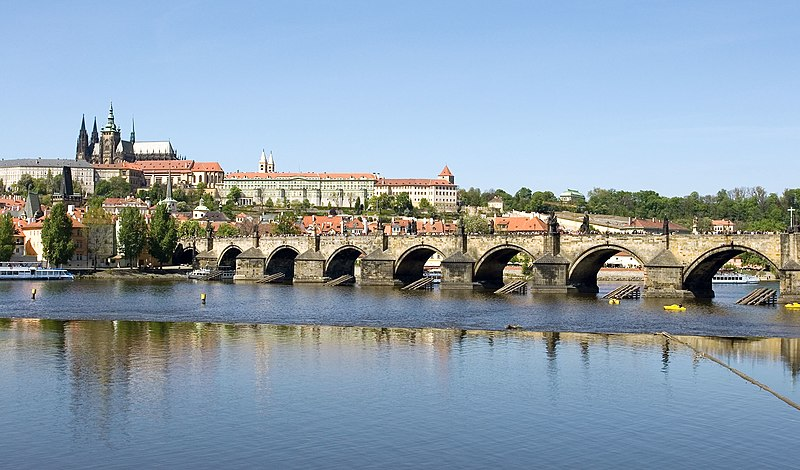The scene is so peaceful. Can you describe what an early morning on the Charles Bridge might feel like? An early morning on the Charles Bridge is a serene experience. The first rays of sunlight cast a golden hue over the stone statues, giving them a warm glow. The city is still waking up, and the only sounds are the soft murmur of the Vltava River and the distant chiming of church bells. A light mist might hover over the water, creating a mystical atmosphere. The bridge is quiet, with only a few early risers taking a stroll or heading to work, allowing you to absorb the historical ambiance and beauty of Prague in solitude. 